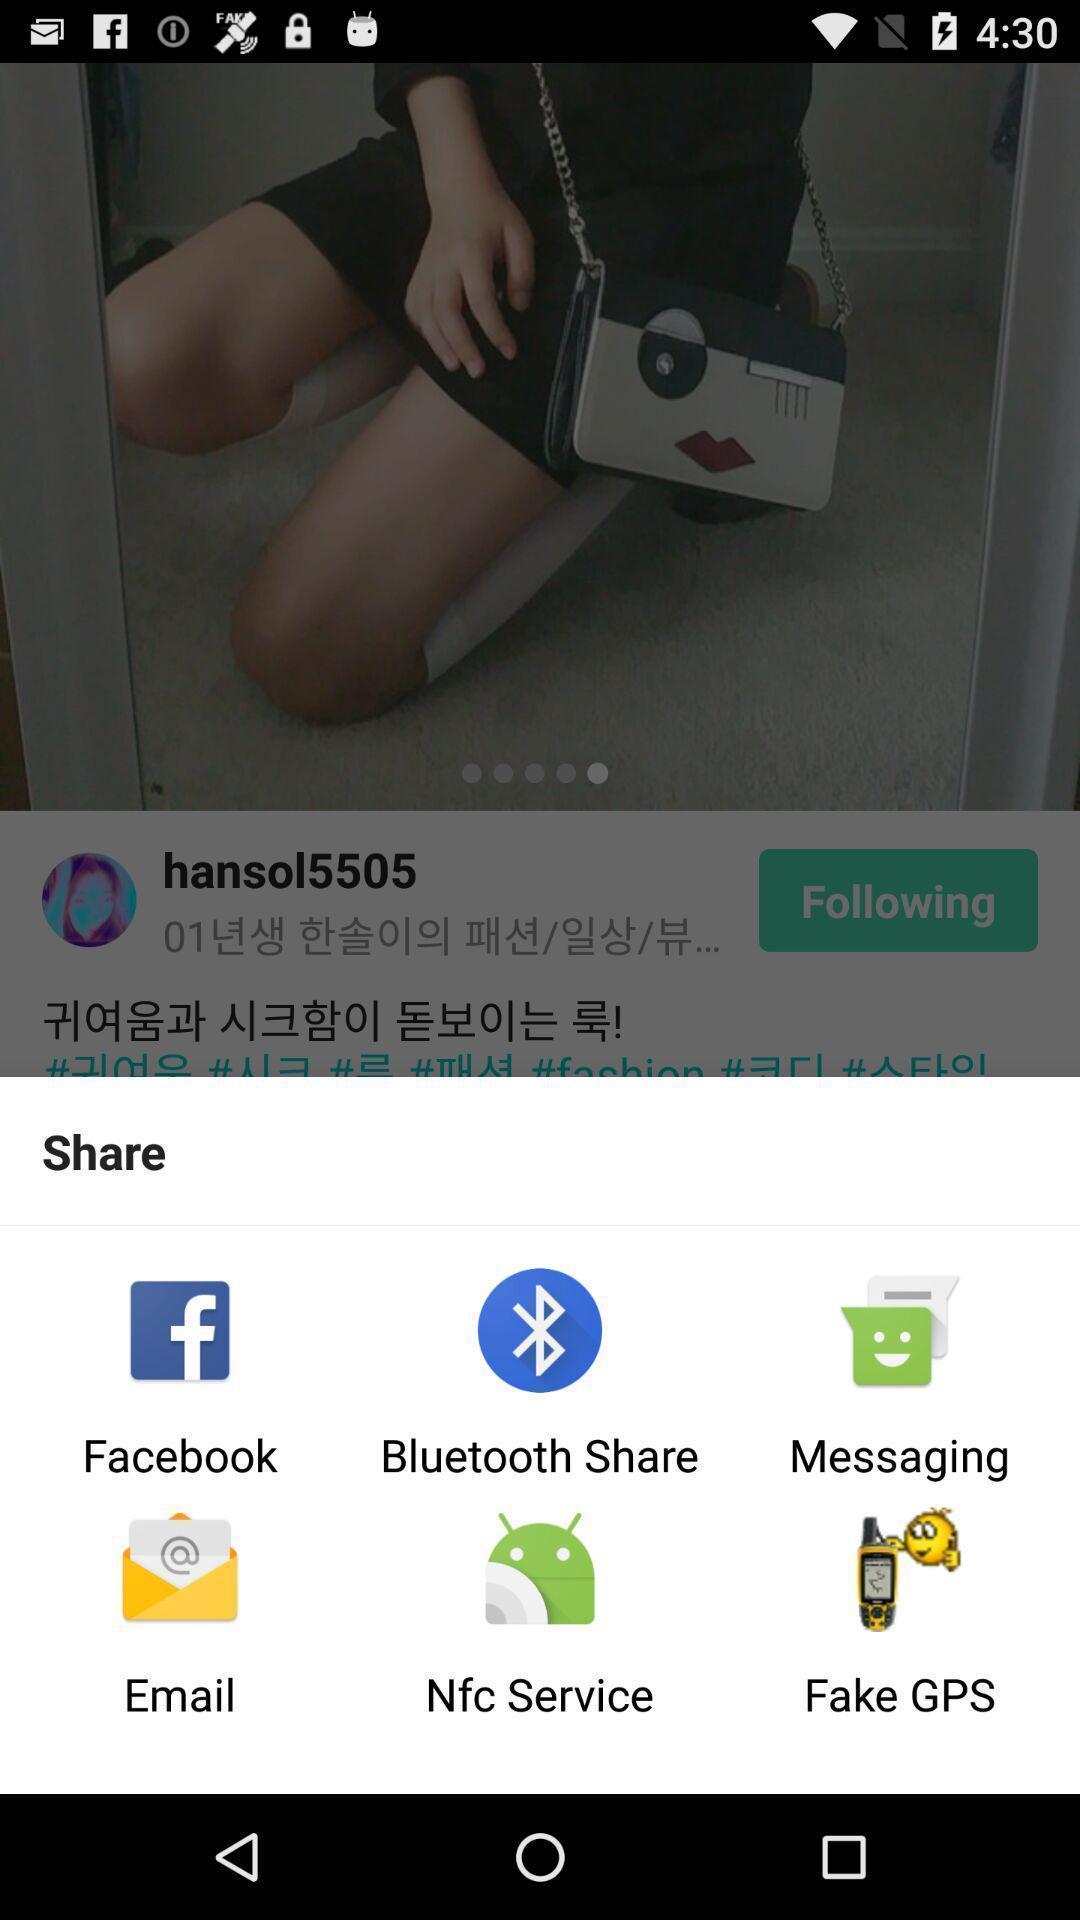Summarize the main components in this picture. Popup showing different apps to share. 